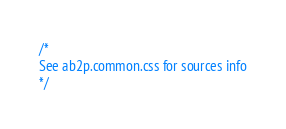Convert code to text. <code><loc_0><loc_0><loc_500><loc_500><_CSS_>/*
See ab2p.common.css for sources info
*/</code> 